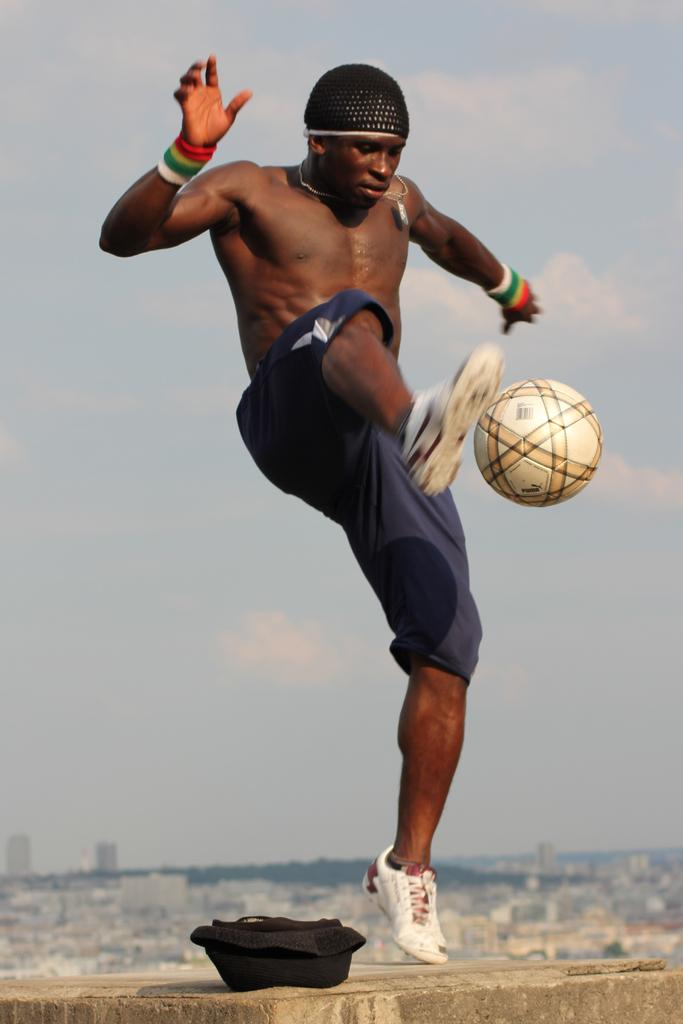Who is the main subject in the image? There is a man in the image. What is the man doing in the image? The man is playing with a football. What can be seen in the background of the image? There is a sky visible in the background of the image. What is the condition of the sky in the image? There are clouds in the sky. What object is on the floor in the image? There is a black bag on the floor in the image. Can you tell me how many boats are visible in the image? There are no boats present in the image; it features a man playing with a football, a sky with clouds, and a black bag on the floor. 